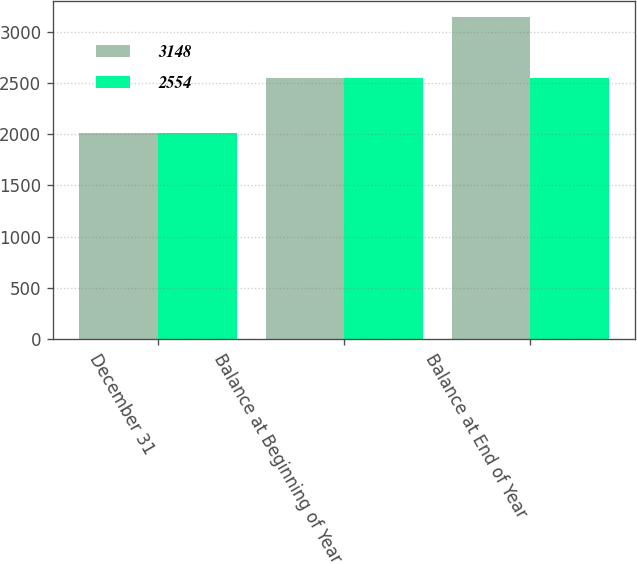Convert chart. <chart><loc_0><loc_0><loc_500><loc_500><stacked_bar_chart><ecel><fcel>December 31<fcel>Balance at Beginning of Year<fcel>Balance at End of Year<nl><fcel>3148<fcel>2017<fcel>2554<fcel>3148<nl><fcel>2554<fcel>2016<fcel>2554<fcel>2554<nl></chart> 